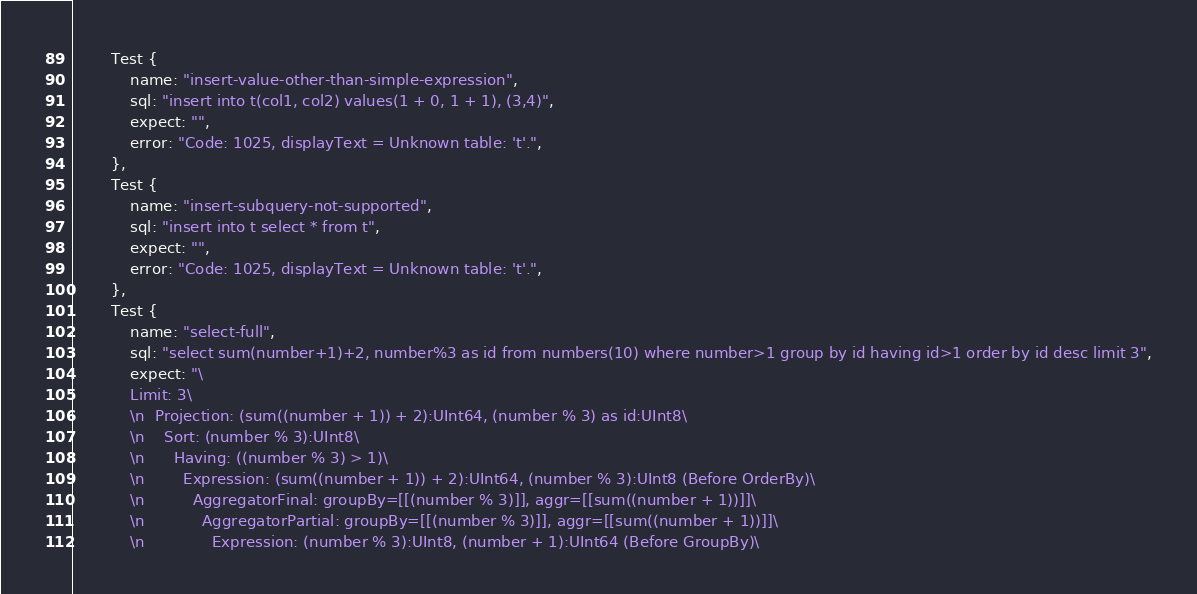Convert code to text. <code><loc_0><loc_0><loc_500><loc_500><_Rust_>        Test {
            name: "insert-value-other-than-simple-expression",
            sql: "insert into t(col1, col2) values(1 + 0, 1 + 1), (3,4)",
            expect: "",
            error: "Code: 1025, displayText = Unknown table: 't'.",
        },
        Test {
            name: "insert-subquery-not-supported",
            sql: "insert into t select * from t",
            expect: "",
            error: "Code: 1025, displayText = Unknown table: 't'.",
        },
        Test {
            name: "select-full",
            sql: "select sum(number+1)+2, number%3 as id from numbers(10) where number>1 group by id having id>1 order by id desc limit 3",
            expect: "\
            Limit: 3\
            \n  Projection: (sum((number + 1)) + 2):UInt64, (number % 3) as id:UInt8\
            \n    Sort: (number % 3):UInt8\
            \n      Having: ((number % 3) > 1)\
            \n        Expression: (sum((number + 1)) + 2):UInt64, (number % 3):UInt8 (Before OrderBy)\
            \n          AggregatorFinal: groupBy=[[(number % 3)]], aggr=[[sum((number + 1))]]\
            \n            AggregatorPartial: groupBy=[[(number % 3)]], aggr=[[sum((number + 1))]]\
            \n              Expression: (number % 3):UInt8, (number + 1):UInt64 (Before GroupBy)\</code> 